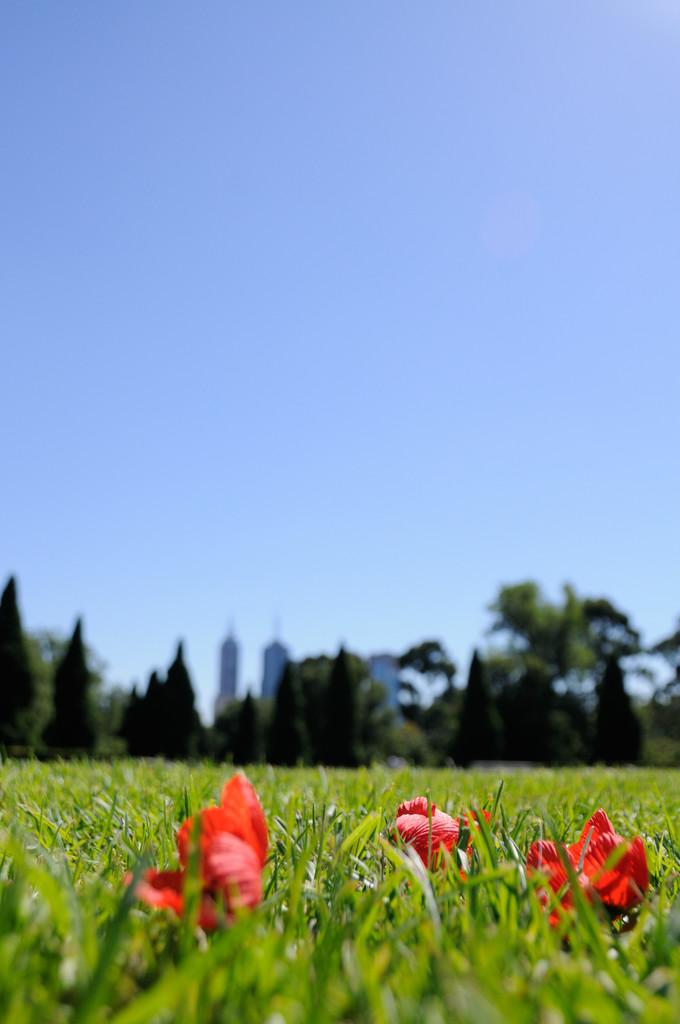What type of flowers can be seen in the image? There are red color flowers in the image. Where are the flowers located? The flowers are on the grass. What can be seen in the background of the image? There are trees, tower buildings, and a blue sky visible in the background. How would you describe the focus of the image? The flowers on the grass are in focus, while the background is blurred. Can you see a pig kicking a ball in the image? No, there is no pig or ball present in the image. 